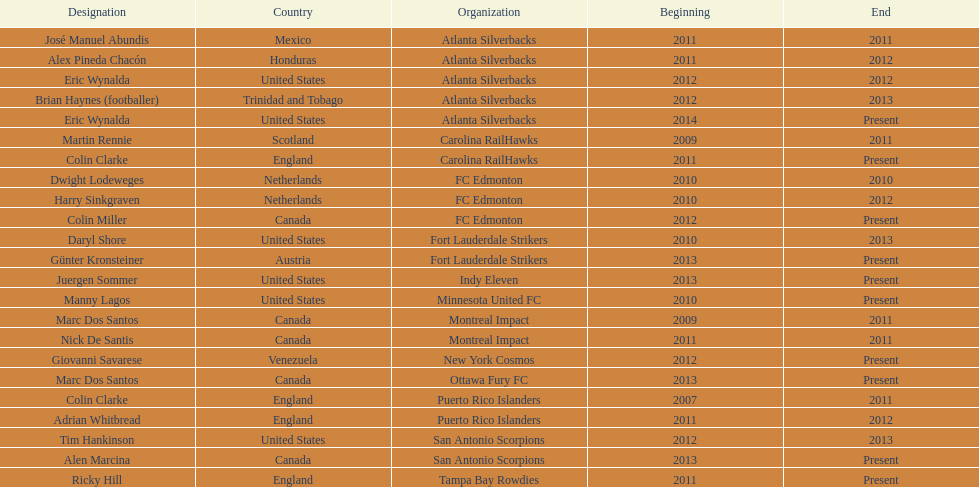What same country did marc dos santos coach as colin miller? Canada. 